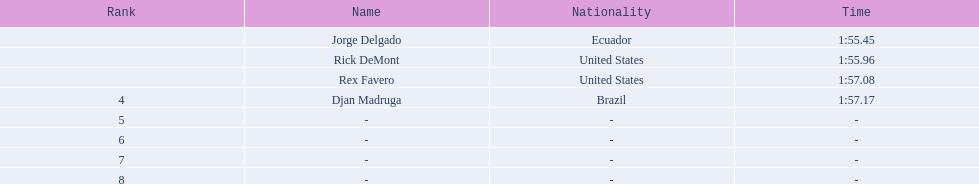Favero finished in 1:57.08. what was the next time? 1:57.17. 